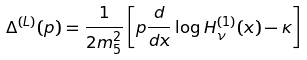<formula> <loc_0><loc_0><loc_500><loc_500>\Delta ^ { ( L ) } ( p ) = \frac { 1 } { 2 m ^ { 2 } _ { 5 } } \left [ p \frac { d } { d x } \log H _ { \nu } ^ { ( 1 ) } ( x ) - \kappa \right ]</formula> 